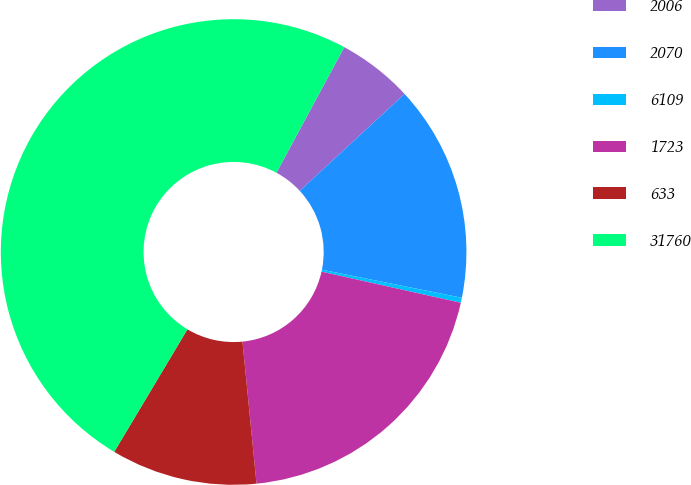Convert chart. <chart><loc_0><loc_0><loc_500><loc_500><pie_chart><fcel>2006<fcel>2070<fcel>6109<fcel>1723<fcel>633<fcel>31760<nl><fcel>5.24%<fcel>15.03%<fcel>0.35%<fcel>19.93%<fcel>10.14%<fcel>49.31%<nl></chart> 